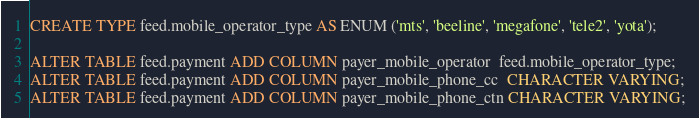Convert code to text. <code><loc_0><loc_0><loc_500><loc_500><_SQL_>CREATE TYPE feed.mobile_operator_type AS ENUM ('mts', 'beeline', 'megafone', 'tele2', 'yota');

ALTER TABLE feed.payment ADD COLUMN payer_mobile_operator  feed.mobile_operator_type;
ALTER TABLE feed.payment ADD COLUMN payer_mobile_phone_cc  CHARACTER VARYING;
ALTER TABLE feed.payment ADD COLUMN payer_mobile_phone_ctn CHARACTER VARYING;</code> 